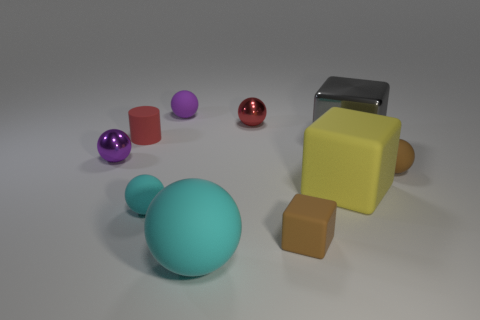Subtract all metal cubes. How many cubes are left? 2 Subtract all yellow cubes. How many purple spheres are left? 2 Subtract all cyan spheres. How many spheres are left? 4 Subtract all cubes. How many objects are left? 7 Add 2 red cylinders. How many red cylinders are left? 3 Add 3 big gray metallic blocks. How many big gray metallic blocks exist? 4 Subtract 0 blue cubes. How many objects are left? 10 Subtract all cyan balls. Subtract all brown cylinders. How many balls are left? 4 Subtract all big purple matte balls. Subtract all big cyan matte spheres. How many objects are left? 9 